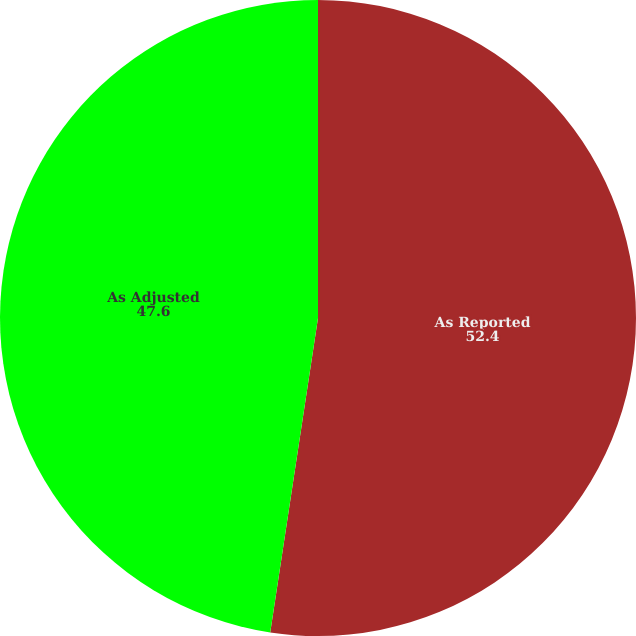<chart> <loc_0><loc_0><loc_500><loc_500><pie_chart><fcel>As Reported<fcel>As Adjusted<nl><fcel>52.4%<fcel>47.6%<nl></chart> 